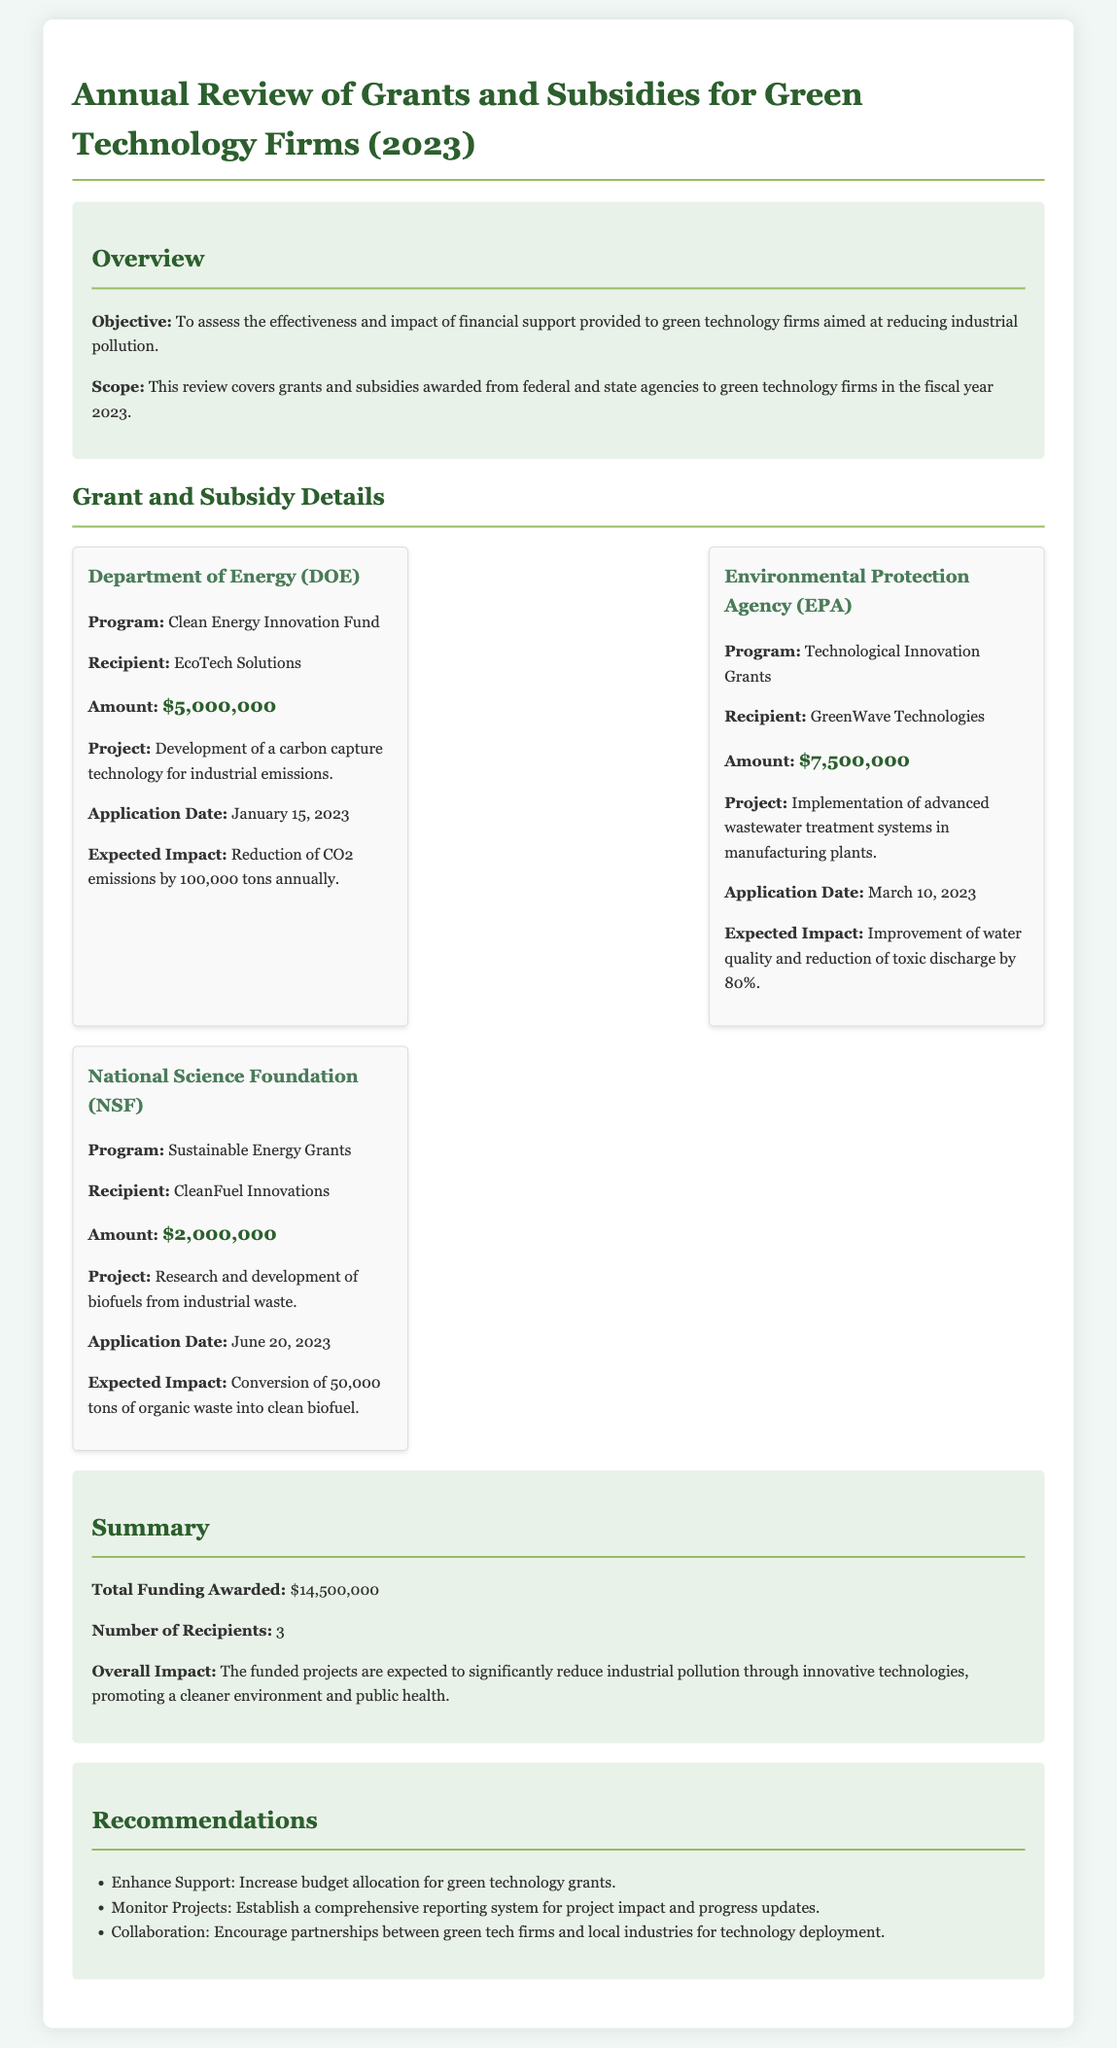What is the objective of the review? The objective is to assess the effectiveness and impact of financial support provided to green technology firms aimed at reducing industrial pollution.
Answer: To assess effectiveness and impact What is the total funding awarded? The total funding awarded is explicitly stated as part of the summary section of the document.
Answer: $14,500,000 Who is the recipient of the grant from the Department of Energy? The recipient name is specifically mentioned in the details about the Department of Energy grant.
Answer: EcoTech Solutions What was the expected impact of GreenWave Technologies' project? The expected impact is detailed in the section concerning the project funded by the EPA grant.
Answer: Improvement of water quality and reduction of toxic discharge by 80% When was CleanFuel Innovations' application submitted? The application date is provided in the grant details for CleanFuel Innovations' NSF grant.
Answer: June 20, 2023 Which agency awarded the largest grant amount? The grant details compare the amounts awarded, indicating which agency provided the most funds.
Answer: Environmental Protection Agency (EPA) What is one recommendation made in the report? The recommendations section lists various suggestions aimed at improving the support for green technology, highlighting one such suggestion.
Answer: Increase budget allocation for green technology grants How many recipients were there in total? This number is mentioned directly in the summary section, providing a clear count of the funded projects.
Answer: 3 